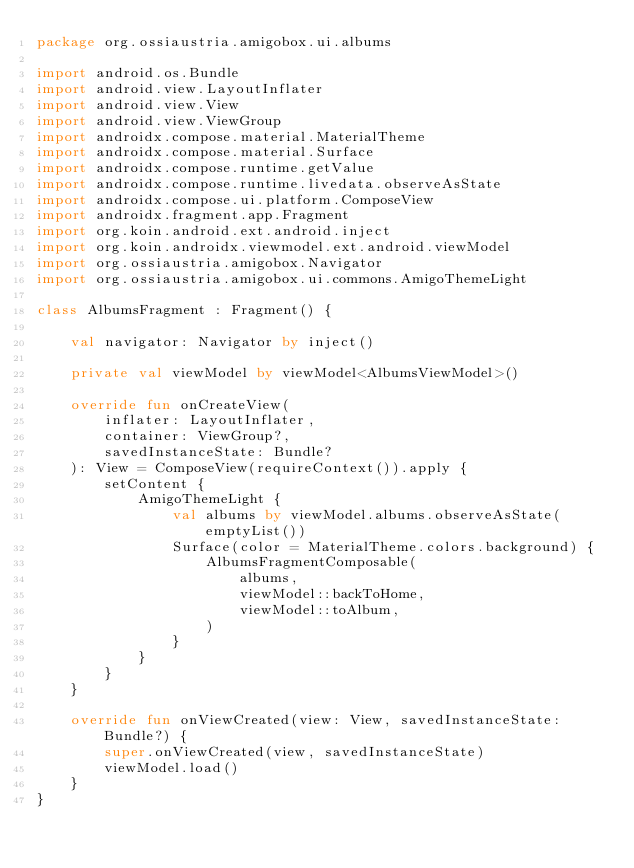<code> <loc_0><loc_0><loc_500><loc_500><_Kotlin_>package org.ossiaustria.amigobox.ui.albums

import android.os.Bundle
import android.view.LayoutInflater
import android.view.View
import android.view.ViewGroup
import androidx.compose.material.MaterialTheme
import androidx.compose.material.Surface
import androidx.compose.runtime.getValue
import androidx.compose.runtime.livedata.observeAsState
import androidx.compose.ui.platform.ComposeView
import androidx.fragment.app.Fragment
import org.koin.android.ext.android.inject
import org.koin.androidx.viewmodel.ext.android.viewModel
import org.ossiaustria.amigobox.Navigator
import org.ossiaustria.amigobox.ui.commons.AmigoThemeLight

class AlbumsFragment : Fragment() {

    val navigator: Navigator by inject()

    private val viewModel by viewModel<AlbumsViewModel>()

    override fun onCreateView(
        inflater: LayoutInflater,
        container: ViewGroup?,
        savedInstanceState: Bundle?
    ): View = ComposeView(requireContext()).apply {
        setContent {
            AmigoThemeLight {
                val albums by viewModel.albums.observeAsState(emptyList())
                Surface(color = MaterialTheme.colors.background) {
                    AlbumsFragmentComposable(
                        albums,
                        viewModel::backToHome,
                        viewModel::toAlbum,
                    )
                }
            }
        }
    }

    override fun onViewCreated(view: View, savedInstanceState: Bundle?) {
        super.onViewCreated(view, savedInstanceState)
        viewModel.load()
    }
}
</code> 